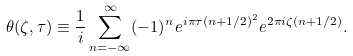Convert formula to latex. <formula><loc_0><loc_0><loc_500><loc_500>\theta ( \zeta , \tau ) \equiv \frac { 1 } { i } \sum _ { n = - \infty } ^ { \infty } ( - 1 ) ^ { n } e ^ { i \pi \tau ( n + 1 / 2 ) ^ { 2 } } e ^ { 2 \pi i \zeta ( n + 1 / 2 ) } .</formula> 